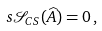<formula> <loc_0><loc_0><loc_500><loc_500>s \mathcal { S } _ { C S } ( \widehat { A } ) = 0 \, ,</formula> 